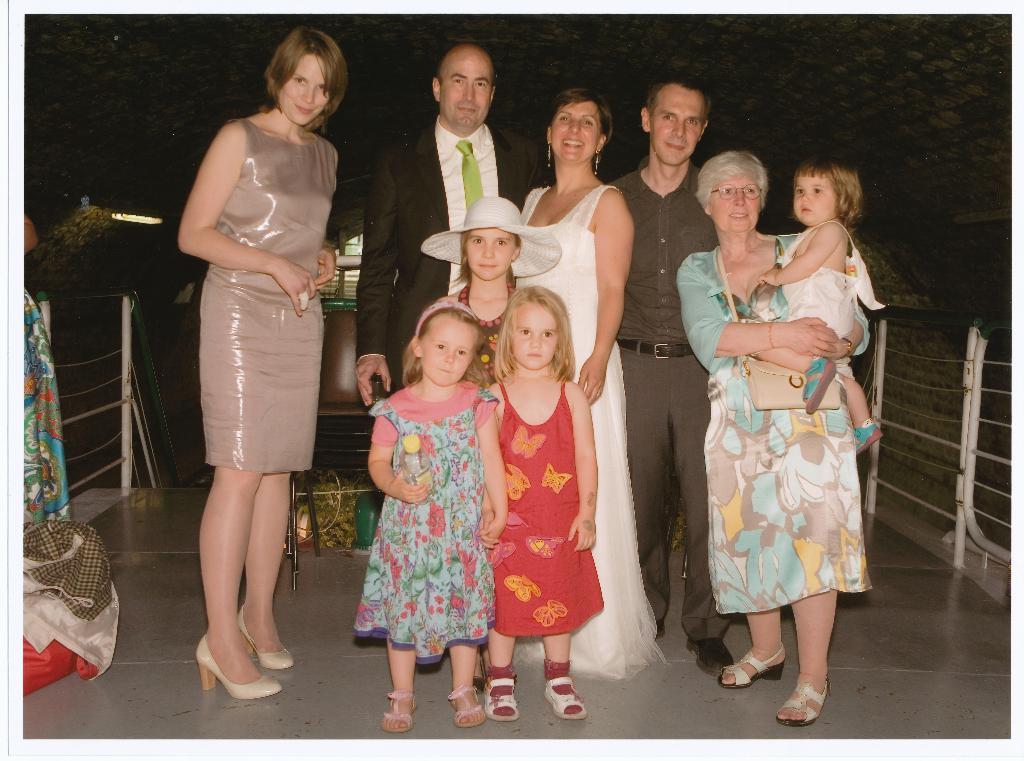Describe this image in one or two sentences. As we can see in the image there are group of people standing in the front. There is a chair, cloths, lights and the background is dark. 